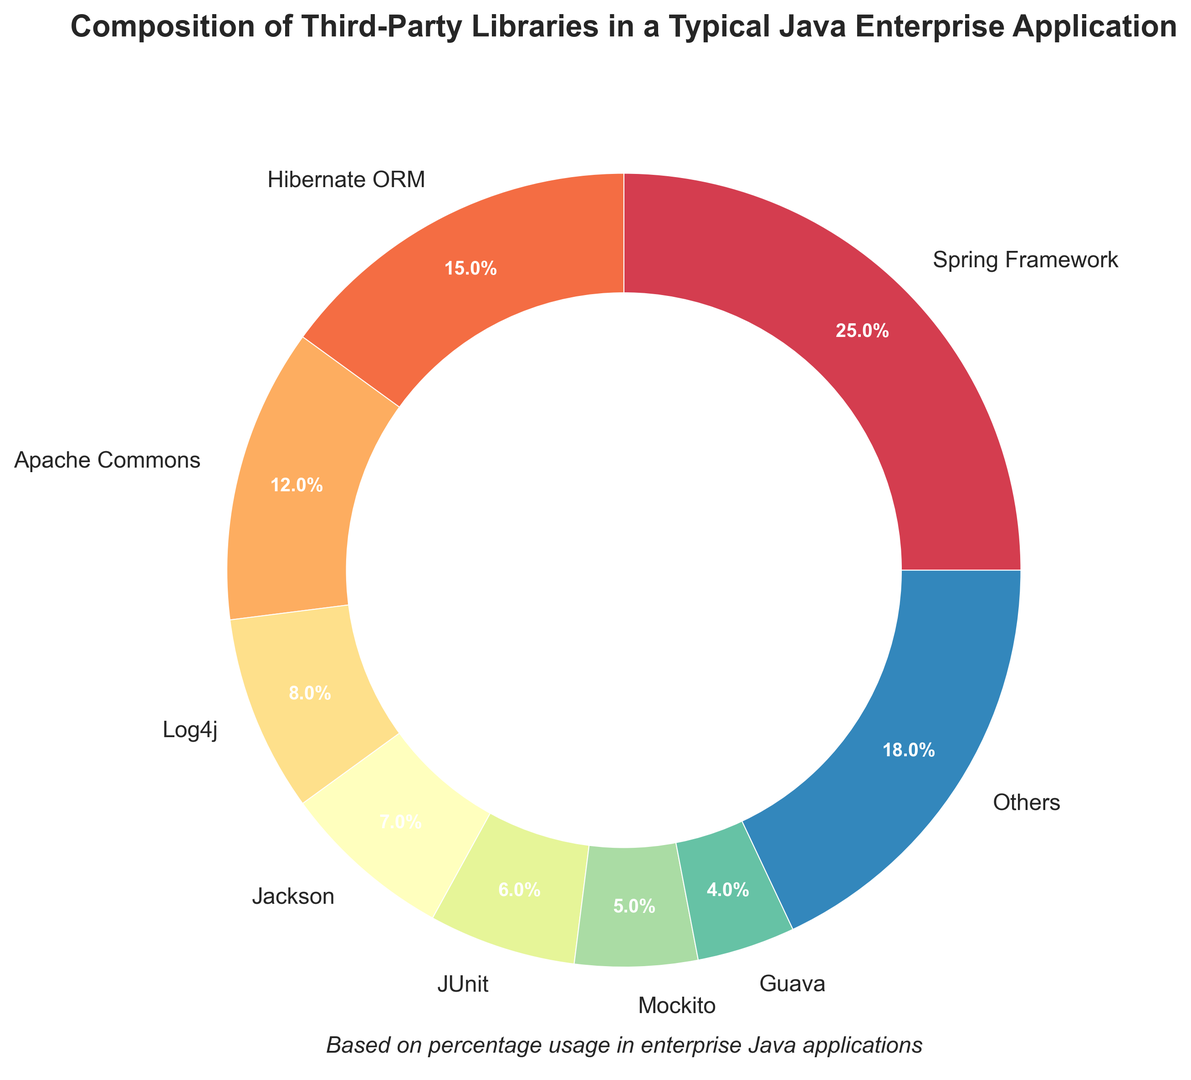Which library has the highest usage percentage? The largest segment in the pie chart represents the library with the highest usage percentage.
Answer: Spring Framework What's the total percentage of the top three libraries combined? Identify the top three libraries by looking at the largest segments in the pie chart, then sum their percentages. Spring Framework (25%) + Hibernate ORM (15%) + Apache Commons (12%) = 52%
Answer: 52% How does the usage of Log4j compare to JUnit? Locate both Log4j and JUnit on the chart and compare their segments. Log4j has 8%, while JUnit has 6%. Thus, Log4j has a higher usage percentage.
Answer: Log4j has a higher usage than JUnit What is the percentage difference between Jackson and Mockito? Calculate the difference between the percentages of Jackson (7%) and Mockito (5%). Subtract 5% from 7% to get 2%.
Answer: 2% Which libraries constitute the "Others" category? The "Others" category is the collection of libraries with smaller percentages not included in the top 8. These can be identified from the list provided: SLF4J, Guava, Apache POI, Gson, Apache HTTP Client, JavaMail, Quartz Scheduler, Apache Commons FileUpload, Lombok.
Answer: Libraries with percentages below the top 8 What proportion of the libraries has a percentage equal to or less than 5%? Count the libraries with percentages 5% or lower. These are Mockito (5%), SLF4J (4%), Guava (4%), Apache POI (3%), Gson (3%), Apache HTTP Client (2%), JavaMail (2%), Quartz Scheduler (2%), Apache Commons FileUpload (1%), Lombok (1%). 10 out of 16 libraries fit this criterion. 10/16 = 62.5%
Answer: 62.5% What percentage of the libraries falls below 10% usage? Count the libraries below 10%. These are Log4j (8%), Jackson (7%), JUnit (6%), Mockito (5%), SLF4J (4%), Guava (4%), Apache POI (3%), Gson (3%), Apache HTTP Client (2%), JavaMail (2%), Quartz Scheduler (2%), Apache Commons FileUpload (1%), Lombok (1%). 13 out of 16 libraries fit this criterion. 13/16 = 81.25%
Answer: 81.25% If Apache Commons and Apache Commons FileUpload are grouped together, what would be their combined percentage? Combine the percentage of Apache Commons (12%) with Apache Commons FileUpload (1%). 12% + 1% = 13%
Answer: 13% What is the visual style used in the pie chart? Describe the design style. The pie chart uses a donut layout with a white circle in the center. Colors are from the Spectral palette, each wedge has distinct colors, and the chart includes labels and percentages.
Answer: Donut chart with Spectral colors Which libraries have very close usage percentages? Identify libraries with similar segment sizes. SLF4J and Guava each have 4%, and Apache HTTP Client, JavaMail, and Quartz Scheduler each have 2%.
Answer: SLF4J and Guava; Apache HTTP Client, JavaMail, and Quartz Scheduler 